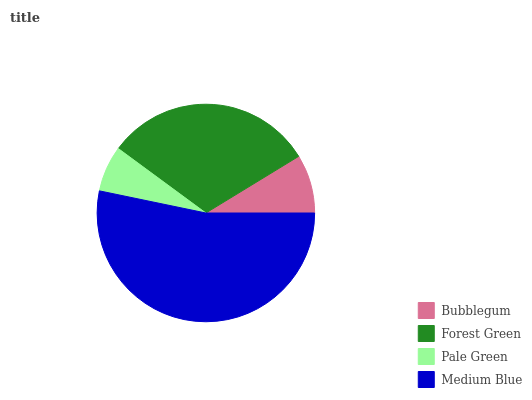Is Pale Green the minimum?
Answer yes or no. Yes. Is Medium Blue the maximum?
Answer yes or no. Yes. Is Forest Green the minimum?
Answer yes or no. No. Is Forest Green the maximum?
Answer yes or no. No. Is Forest Green greater than Bubblegum?
Answer yes or no. Yes. Is Bubblegum less than Forest Green?
Answer yes or no. Yes. Is Bubblegum greater than Forest Green?
Answer yes or no. No. Is Forest Green less than Bubblegum?
Answer yes or no. No. Is Forest Green the high median?
Answer yes or no. Yes. Is Bubblegum the low median?
Answer yes or no. Yes. Is Pale Green the high median?
Answer yes or no. No. Is Pale Green the low median?
Answer yes or no. No. 